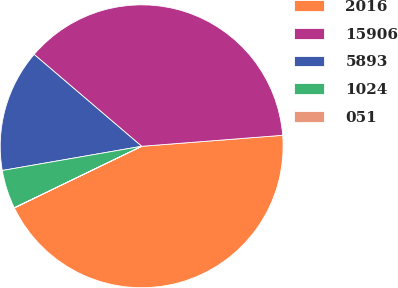Convert chart to OTSL. <chart><loc_0><loc_0><loc_500><loc_500><pie_chart><fcel>2016<fcel>15906<fcel>5893<fcel>1024<fcel>051<nl><fcel>44.06%<fcel>37.51%<fcel>13.99%<fcel>4.42%<fcel>0.02%<nl></chart> 